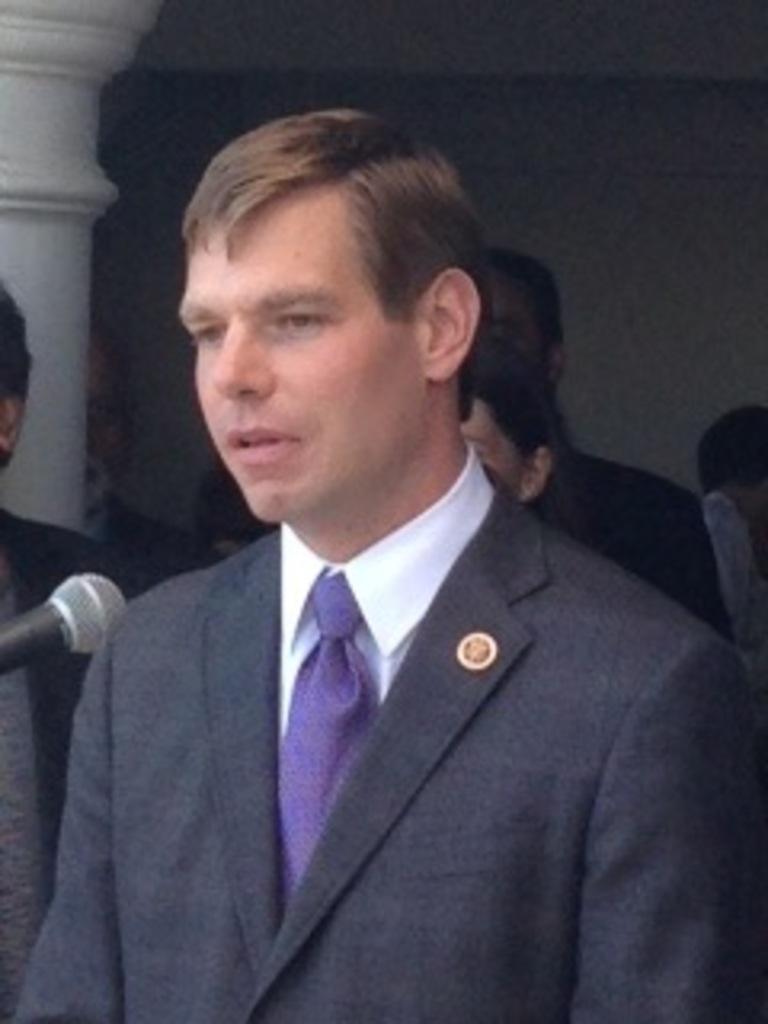Please provide a concise description of this image. In the image there is a man and in front of him there is a mic, behind the man there are other people and a pillar. 